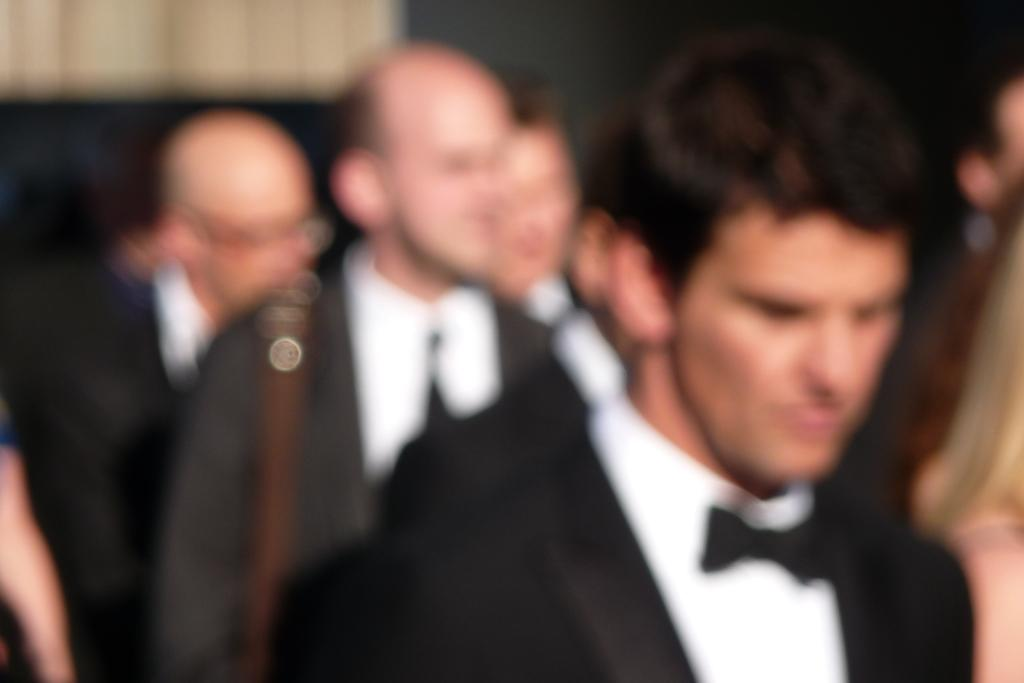How many people are in the image? There are persons in the image. Can you describe the attire of one of the persons? One person is wearing a suit and tie. What type of cloud can be seen in the image? There is no cloud present in the image, as it only features persons, one of whom is wearing a suit and tie. 